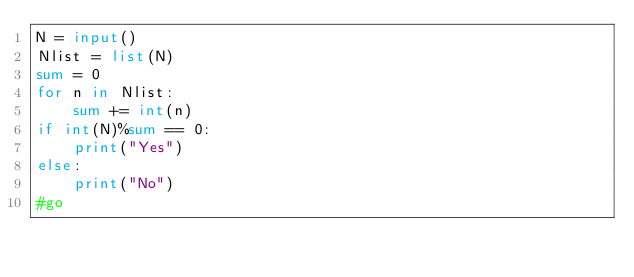Convert code to text. <code><loc_0><loc_0><loc_500><loc_500><_Python_>N = input()
Nlist = list(N)
sum = 0
for n in Nlist:
    sum += int(n)
if int(N)%sum == 0:
    print("Yes")
else:
    print("No")
#go
</code> 